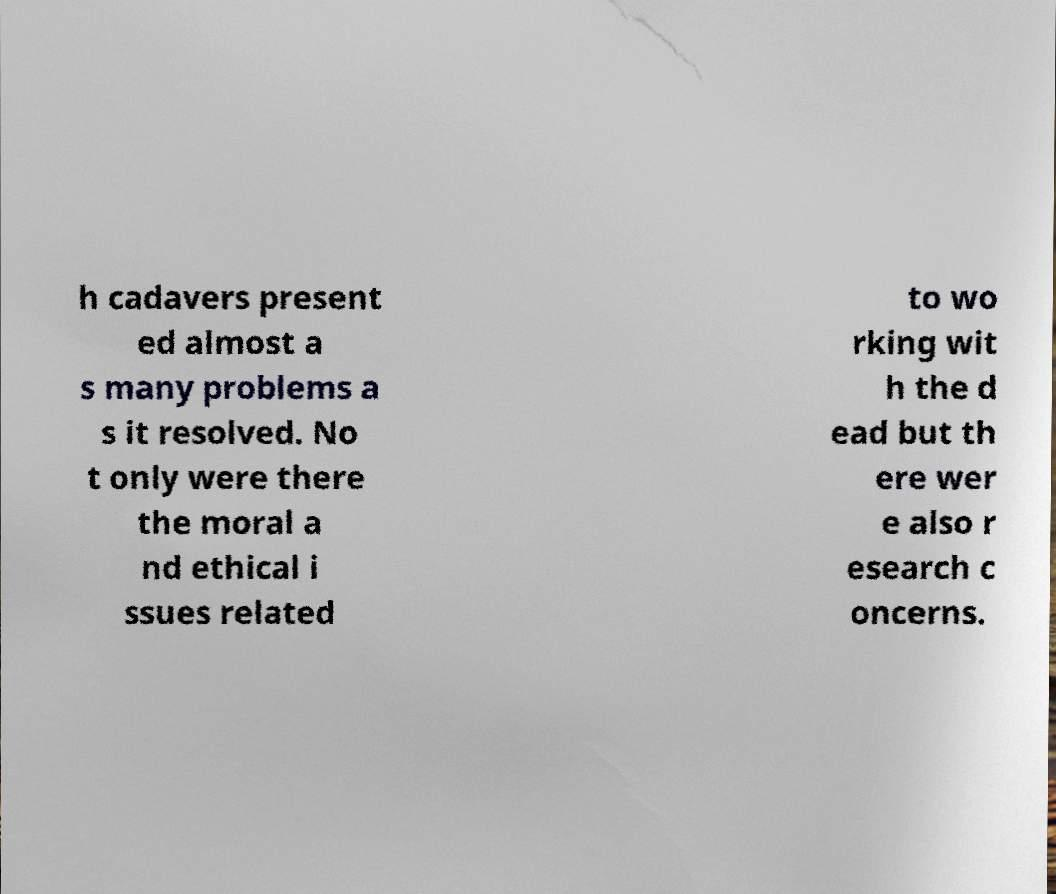Please identify and transcribe the text found in this image. h cadavers present ed almost a s many problems a s it resolved. No t only were there the moral a nd ethical i ssues related to wo rking wit h the d ead but th ere wer e also r esearch c oncerns. 